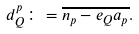<formula> <loc_0><loc_0><loc_500><loc_500>d _ { Q } ^ { p } \colon = \overline { n _ { p } - e _ { Q } a _ { p } } .</formula> 